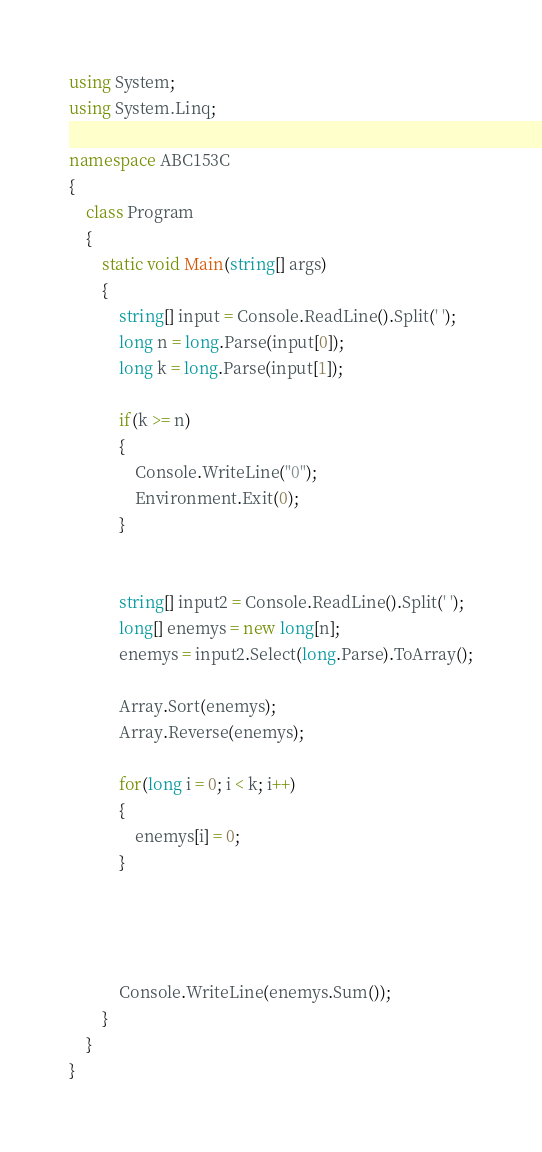<code> <loc_0><loc_0><loc_500><loc_500><_C#_>using System;
using System.Linq;

namespace ABC153C
{
    class Program
    {
        static void Main(string[] args)
        {
            string[] input = Console.ReadLine().Split(' ');
            long n = long.Parse(input[0]);
            long k = long.Parse(input[1]);

            if(k >= n)
            {
                Console.WriteLine("0");
                Environment.Exit(0);
            }


            string[] input2 = Console.ReadLine().Split(' ');
            long[] enemys = new long[n];
            enemys = input2.Select(long.Parse).ToArray();

            Array.Sort(enemys);
            Array.Reverse(enemys);

            for(long i = 0; i < k; i++)
            {
                enemys[i] = 0;
            }




            Console.WriteLine(enemys.Sum());
        }
    }
}
</code> 